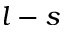Convert formula to latex. <formula><loc_0><loc_0><loc_500><loc_500>l - s</formula> 